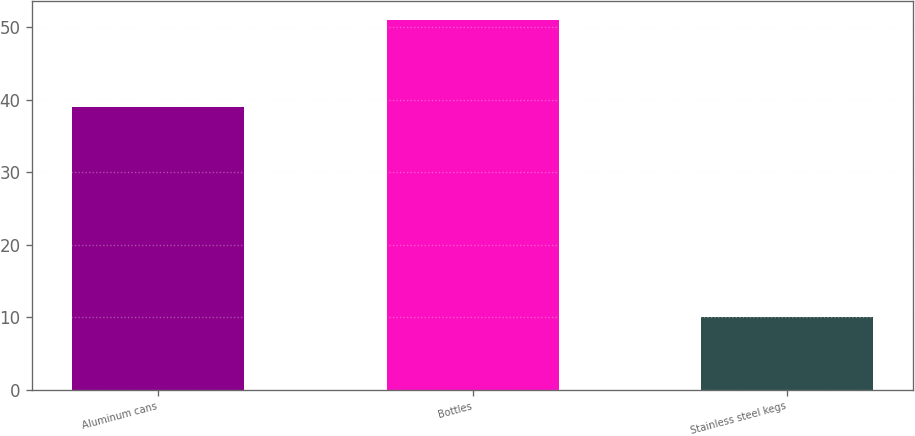Convert chart to OTSL. <chart><loc_0><loc_0><loc_500><loc_500><bar_chart><fcel>Aluminum cans<fcel>Bottles<fcel>Stainless steel kegs<nl><fcel>39<fcel>51<fcel>10<nl></chart> 